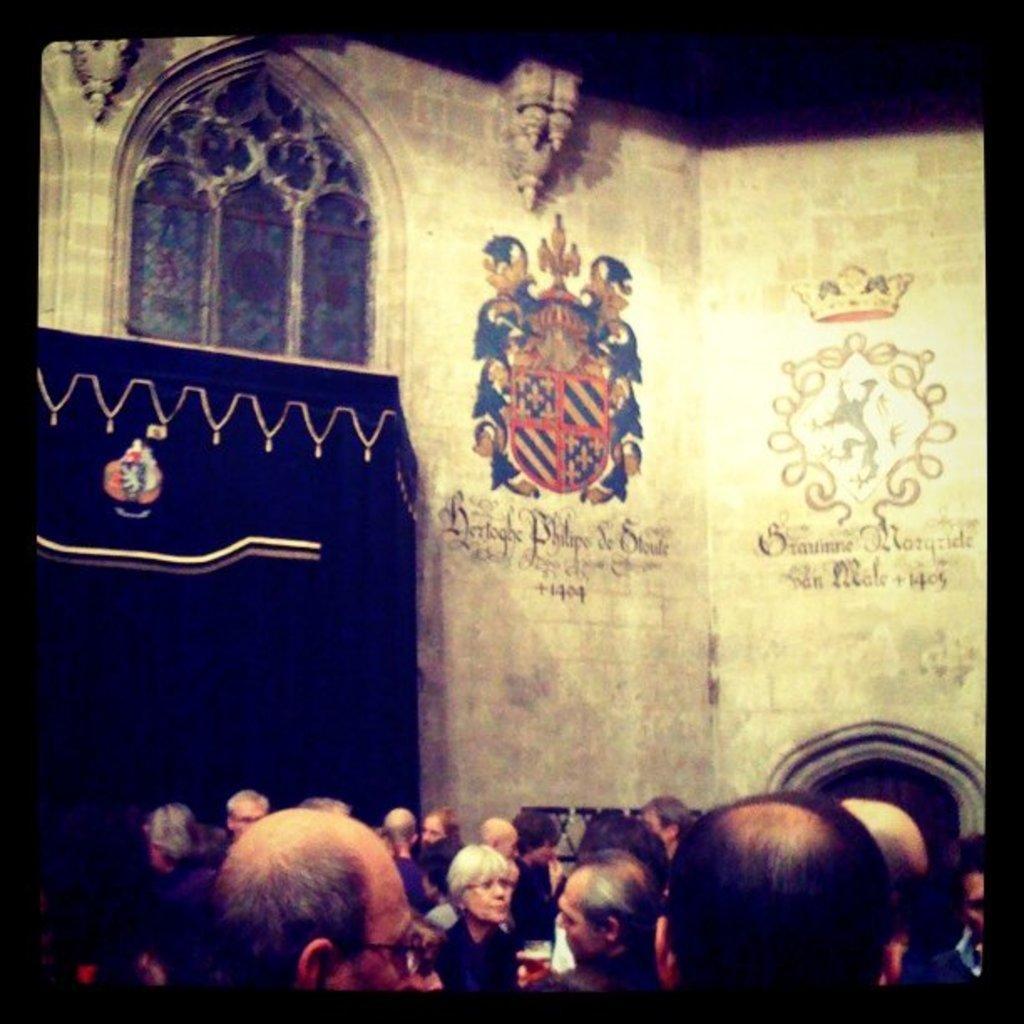In one or two sentences, can you explain what this image depicts? In this picture we can see a group of people standing on the path and a person is holding a glass and behind the people there is a wall. 